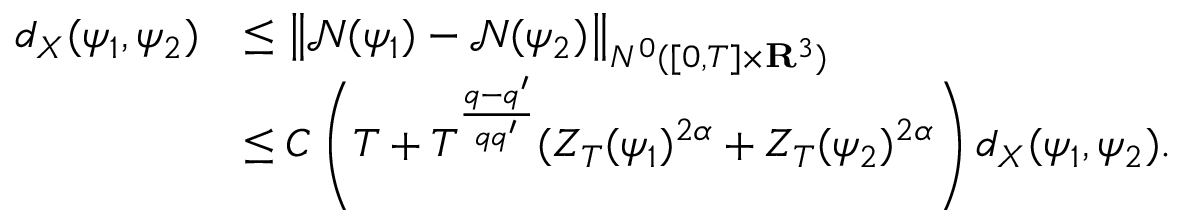Convert formula to latex. <formula><loc_0><loc_0><loc_500><loc_500>\begin{array} { r l } { d _ { X } ( \psi _ { 1 } , \psi _ { 2 } ) } & { \leq \left \| \mathcal { N } ( \psi _ { 1 } ) - \mathcal { N } ( \psi _ { 2 } ) \right \| _ { N ^ { 0 } ( [ 0 , T ] \times { \mathbf R } ^ { 3 } ) } } \\ & { \leq C \left ( T + T ^ { \frac { q - q ^ { \prime } } { q q ^ { \prime } } } ( Z _ { T } ( \psi _ { 1 } ) ^ { 2 \alpha } + Z _ { T } ( \psi _ { 2 } ) ^ { 2 \alpha } \right ) d _ { X } ( \psi _ { 1 } , \psi _ { 2 } ) . } \end{array}</formula> 